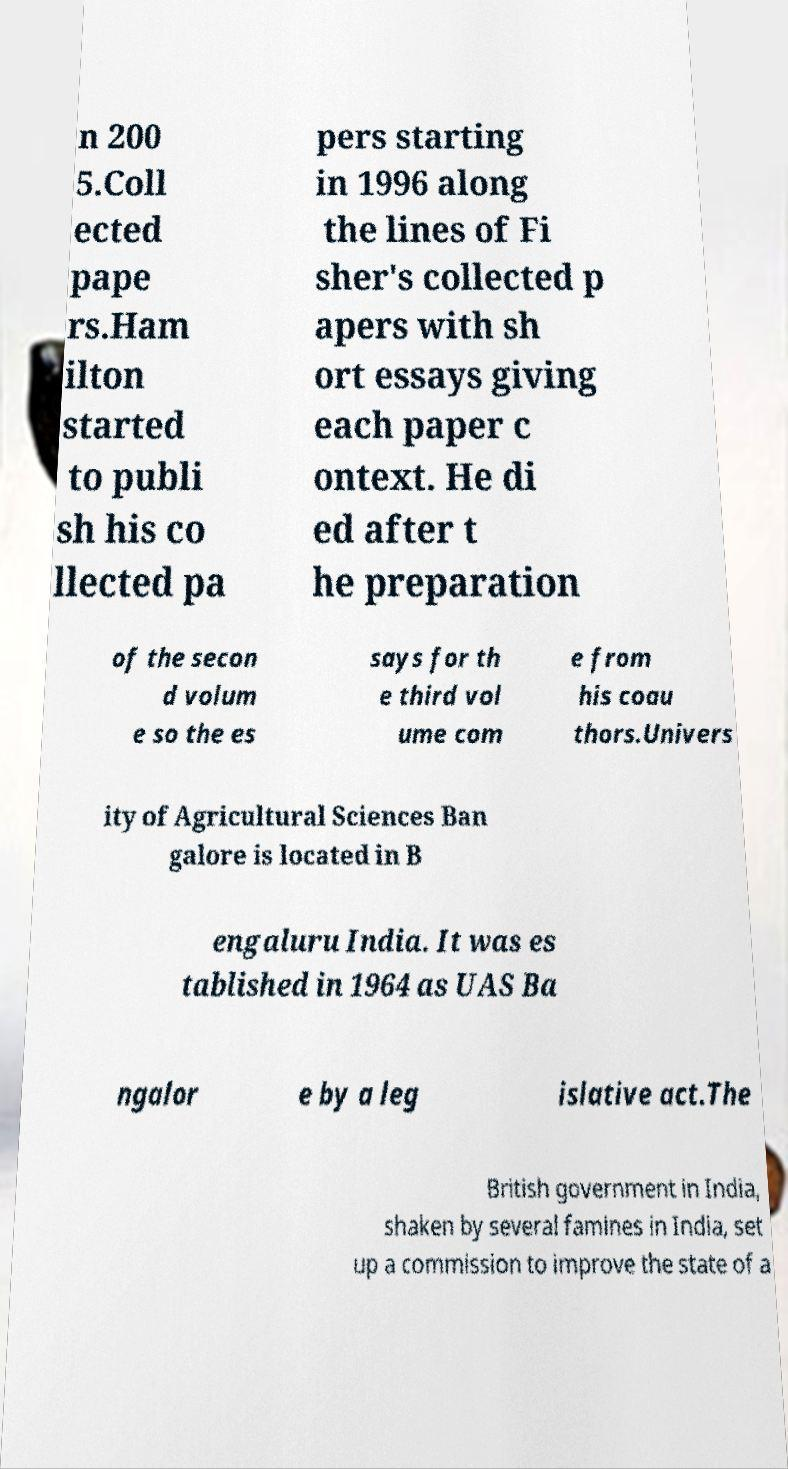I need the written content from this picture converted into text. Can you do that? n 200 5.Coll ected pape rs.Ham ilton started to publi sh his co llected pa pers starting in 1996 along the lines of Fi sher's collected p apers with sh ort essays giving each paper c ontext. He di ed after t he preparation of the secon d volum e so the es says for th e third vol ume com e from his coau thors.Univers ity of Agricultural Sciences Ban galore is located in B engaluru India. It was es tablished in 1964 as UAS Ba ngalor e by a leg islative act.The British government in India, shaken by several famines in India, set up a commission to improve the state of a 